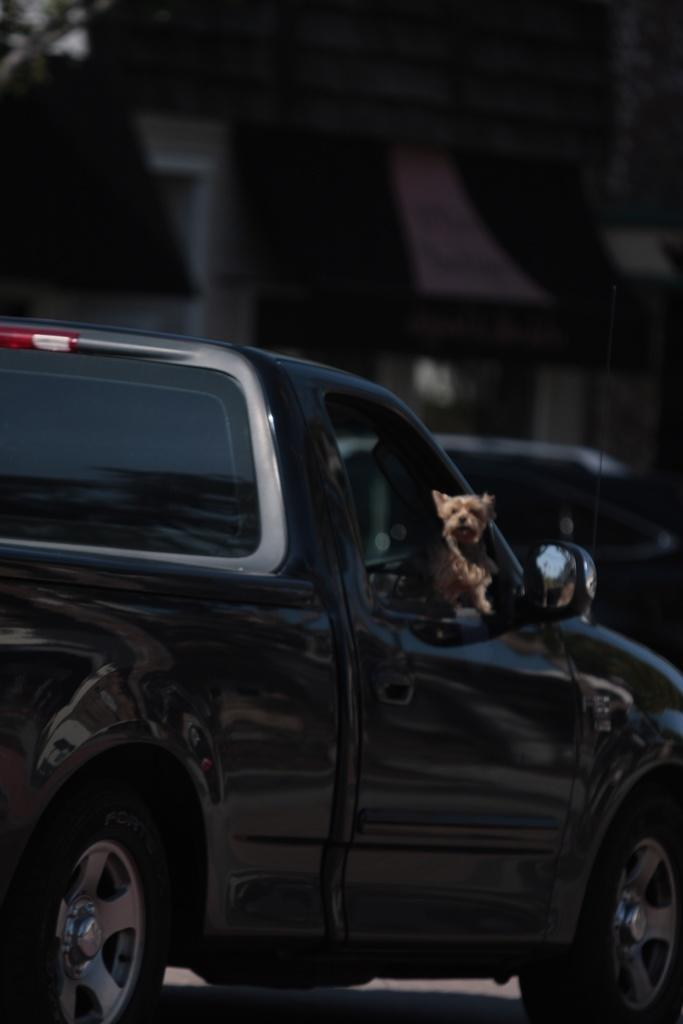What is the main subject of the image? There is a car in the image. Is there anything else inside the car? Yes, there is a dog inside the car. How many ants can be seen crawling on the car in the image? There are no ants visible in the image. Who is the owner of the car in the image? The owner of the car is not visible or identifiable in the image. 